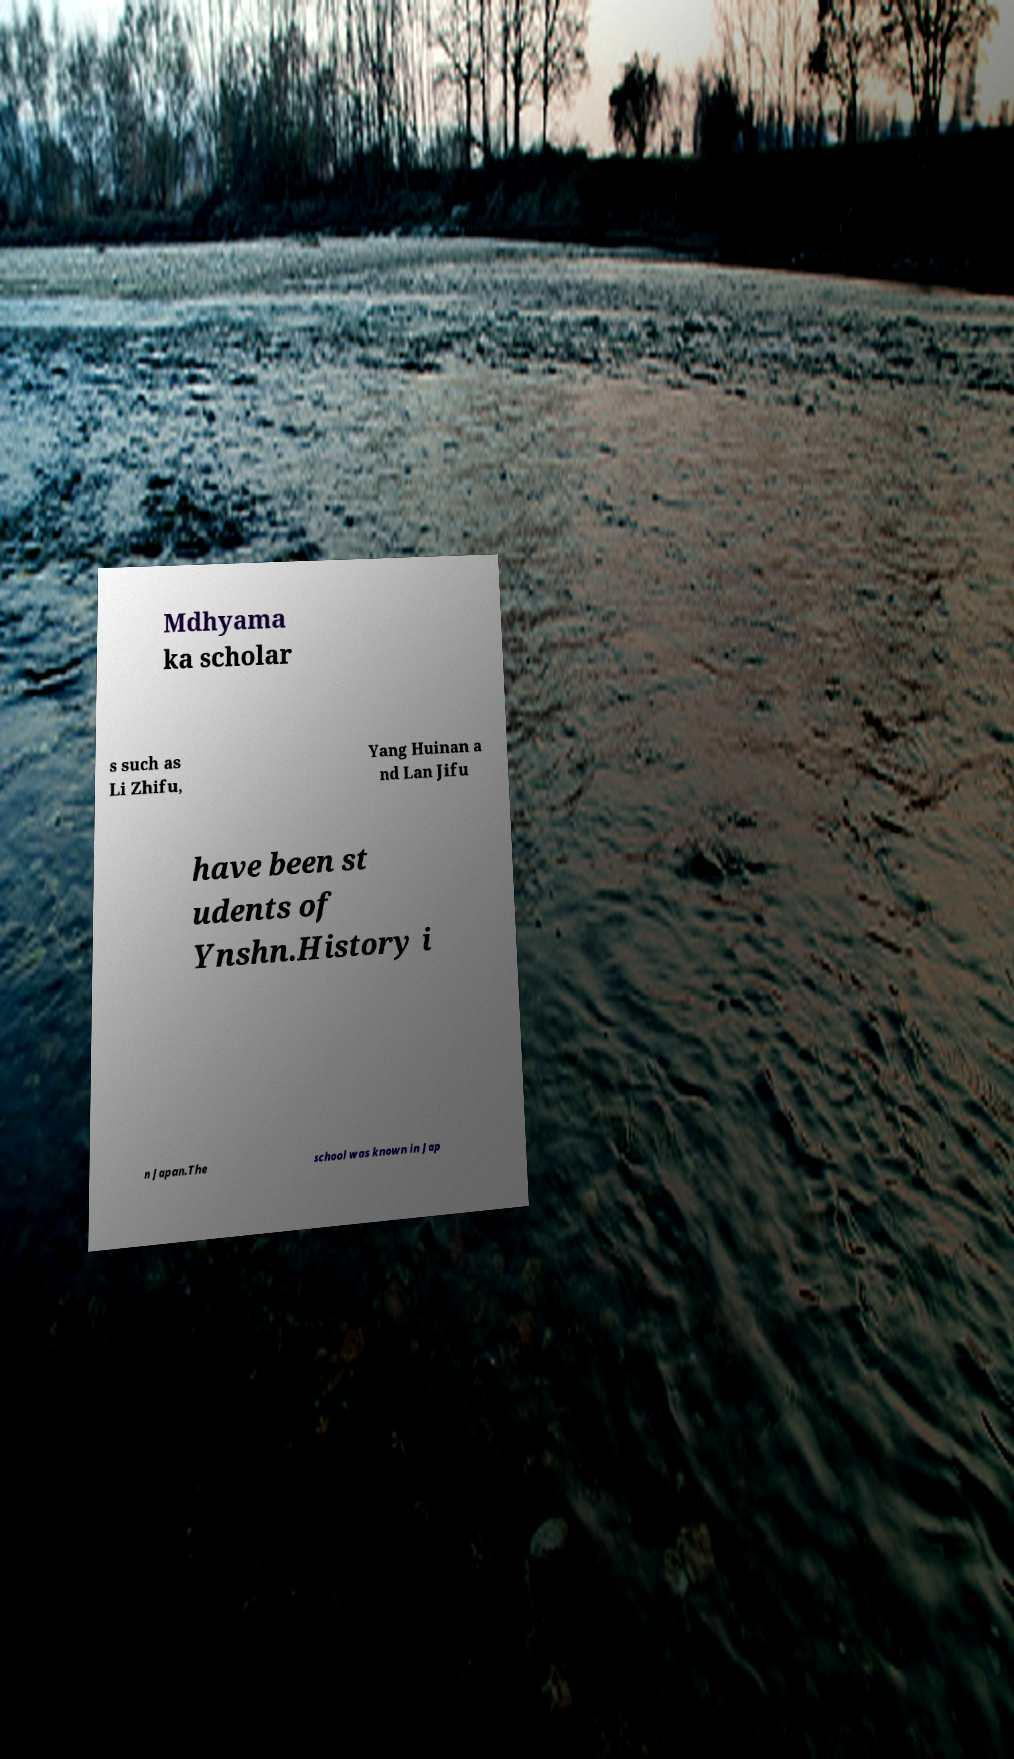Could you assist in decoding the text presented in this image and type it out clearly? Mdhyama ka scholar s such as Li Zhifu, Yang Huinan a nd Lan Jifu have been st udents of Ynshn.History i n Japan.The school was known in Jap 